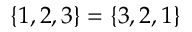Convert formula to latex. <formula><loc_0><loc_0><loc_500><loc_500>\{ 1 , 2 , 3 \} = \{ 3 , 2 , 1 \}</formula> 